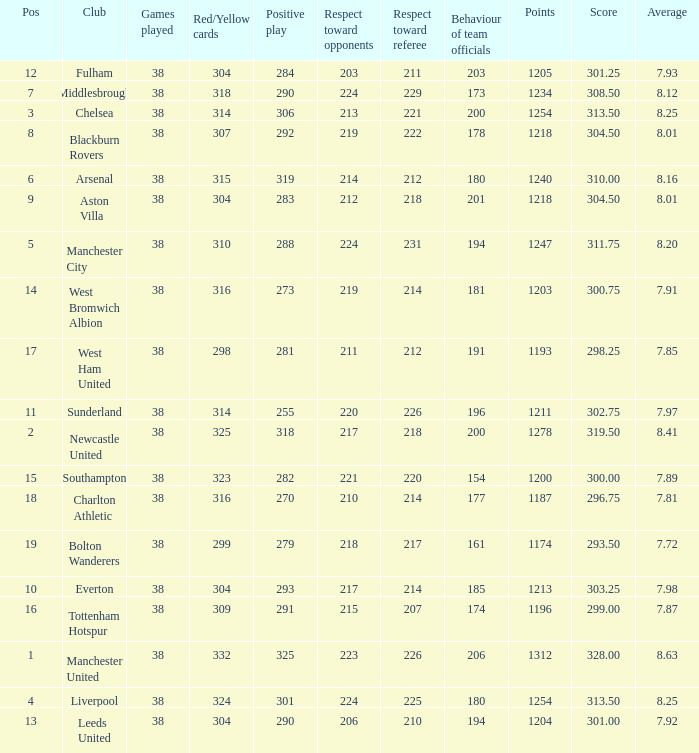Name the most pos for west bromwich albion club 14.0. 